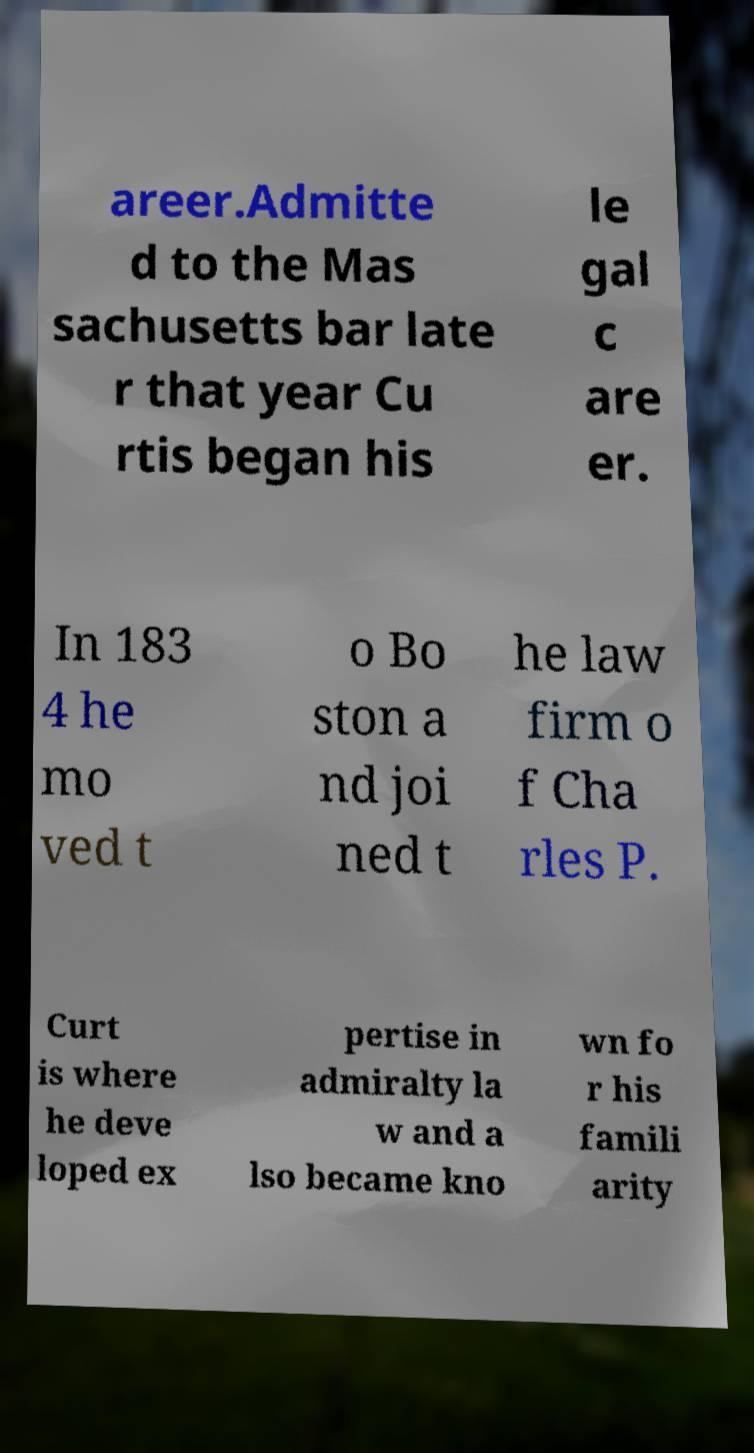What messages or text are displayed in this image? I need them in a readable, typed format. areer.Admitte d to the Mas sachusetts bar late r that year Cu rtis began his le gal c are er. In 183 4 he mo ved t o Bo ston a nd joi ned t he law firm o f Cha rles P. Curt is where he deve loped ex pertise in admiralty la w and a lso became kno wn fo r his famili arity 